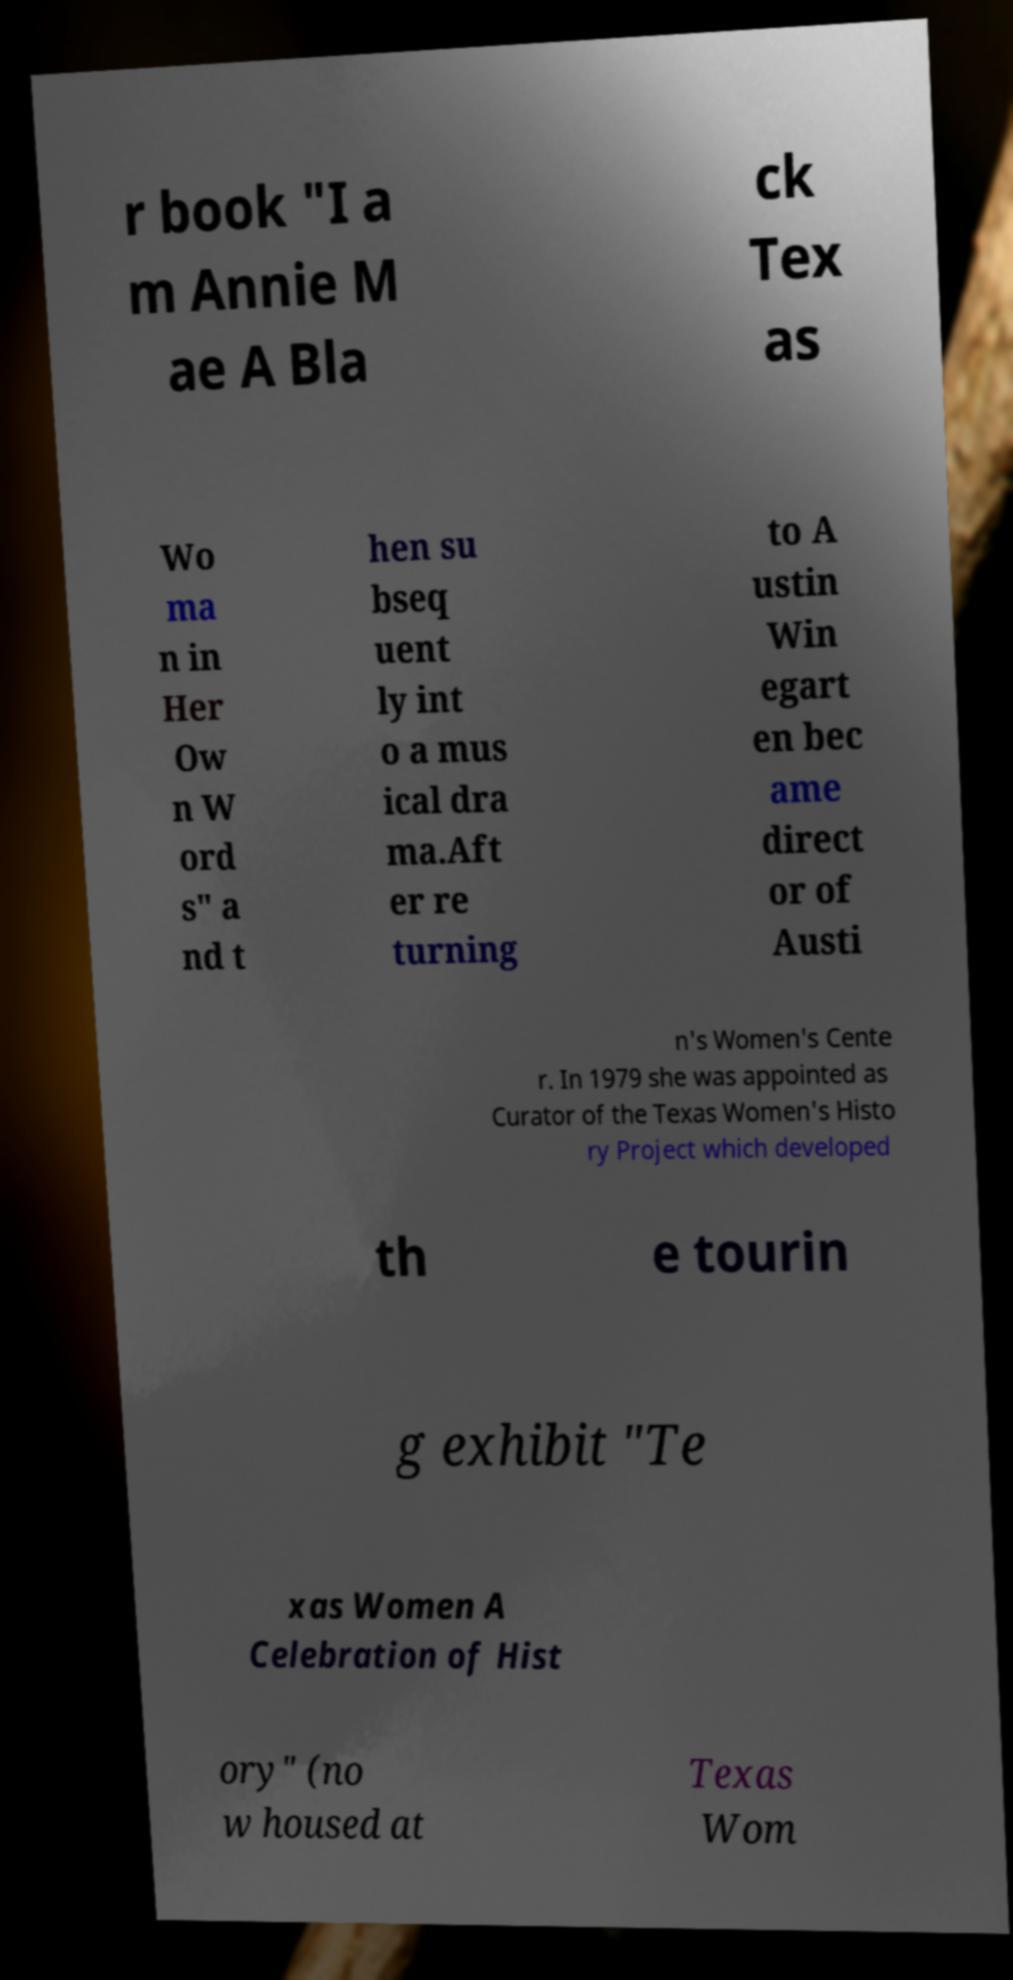Please read and relay the text visible in this image. What does it say? r book "I a m Annie M ae A Bla ck Tex as Wo ma n in Her Ow n W ord s" a nd t hen su bseq uent ly int o a mus ical dra ma.Aft er re turning to A ustin Win egart en bec ame direct or of Austi n's Women's Cente r. In 1979 she was appointed as Curator of the Texas Women's Histo ry Project which developed th e tourin g exhibit "Te xas Women A Celebration of Hist ory" (no w housed at Texas Wom 